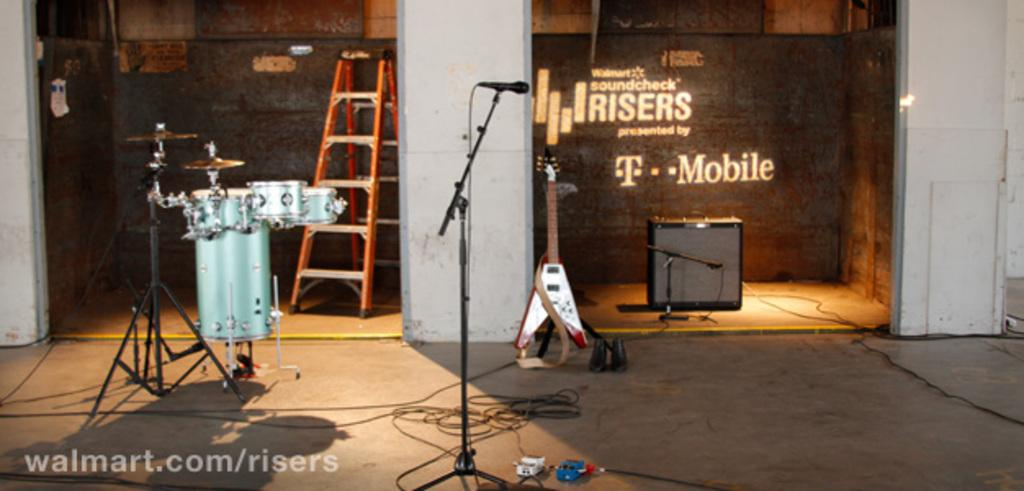What type of musical instruments can be seen in the image? There is a drum set and a guitar in the image. What other equipment is present in the image? There is a ladder, a microphone, and a speaker in the image. Where are these objects located in the image? The objects are placed by the side of a store. What type of dirt can be seen on the rabbit in the image? There is no rabbit present in the image, so there is no dirt to be seen on it. What invention is being used by the band in the image? The image does not show a band or any specific invention being used; it only shows the musical instruments, equipment, and their location. 